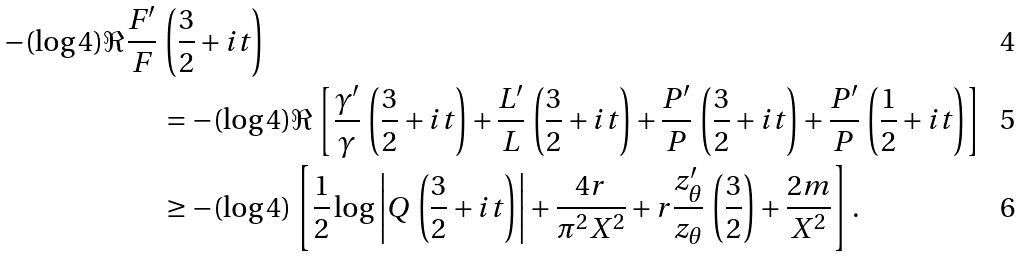Convert formula to latex. <formula><loc_0><loc_0><loc_500><loc_500>- ( \log 4 ) \Re \frac { F ^ { \prime } } { F } \, & \left ( \frac { 3 } { 2 } + i t \right ) \\ & = - ( \log 4 ) \Re \left [ \frac { \gamma ^ { \prime } } { \gamma } \, \left ( \frac { 3 } { 2 } + i t \right ) + \frac { L ^ { \prime } } { L } \, \left ( \frac { 3 } { 2 } + i t \right ) + \frac { P ^ { \prime } } { P } \, \left ( \frac { 3 } { 2 } + i t \right ) + \frac { P ^ { \prime } } { P } \, \left ( \frac { 1 } { 2 } + i t \right ) \right ] \\ & \geq - ( \log 4 ) \left [ \frac { 1 } { 2 } \log \left | Q \, \left ( \frac { 3 } { 2 } + i t \right ) \right | + \frac { 4 r } { \pi ^ { 2 } X ^ { 2 } } + r \frac { z _ { \theta } ^ { \prime } } { z _ { \theta } } \, \left ( \frac { 3 } { 2 } \right ) + \frac { 2 m } { X ^ { 2 } } \right ] .</formula> 